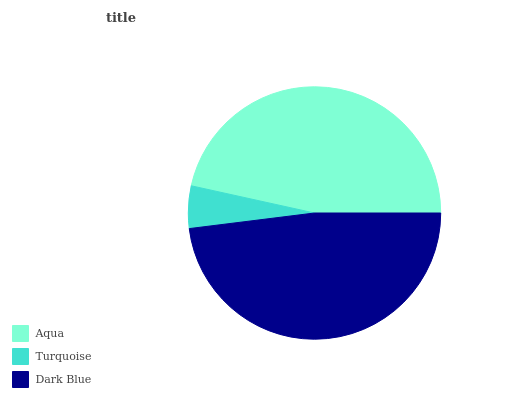Is Turquoise the minimum?
Answer yes or no. Yes. Is Dark Blue the maximum?
Answer yes or no. Yes. Is Dark Blue the minimum?
Answer yes or no. No. Is Turquoise the maximum?
Answer yes or no. No. Is Dark Blue greater than Turquoise?
Answer yes or no. Yes. Is Turquoise less than Dark Blue?
Answer yes or no. Yes. Is Turquoise greater than Dark Blue?
Answer yes or no. No. Is Dark Blue less than Turquoise?
Answer yes or no. No. Is Aqua the high median?
Answer yes or no. Yes. Is Aqua the low median?
Answer yes or no. Yes. Is Dark Blue the high median?
Answer yes or no. No. Is Turquoise the low median?
Answer yes or no. No. 